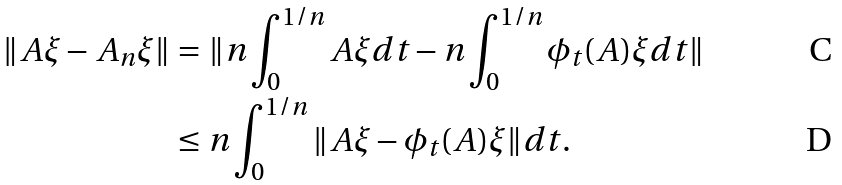Convert formula to latex. <formula><loc_0><loc_0><loc_500><loc_500>\| A \xi - A _ { n } \xi \| & = \| n \int _ { 0 } ^ { 1 / n } A \xi d t - n \int _ { 0 } ^ { 1 / n } \phi _ { t } ( A ) \xi d t \| \\ & \leq n \int _ { 0 } ^ { 1 / n } \| A \xi - \phi _ { t } ( A ) \xi \| d t .</formula> 